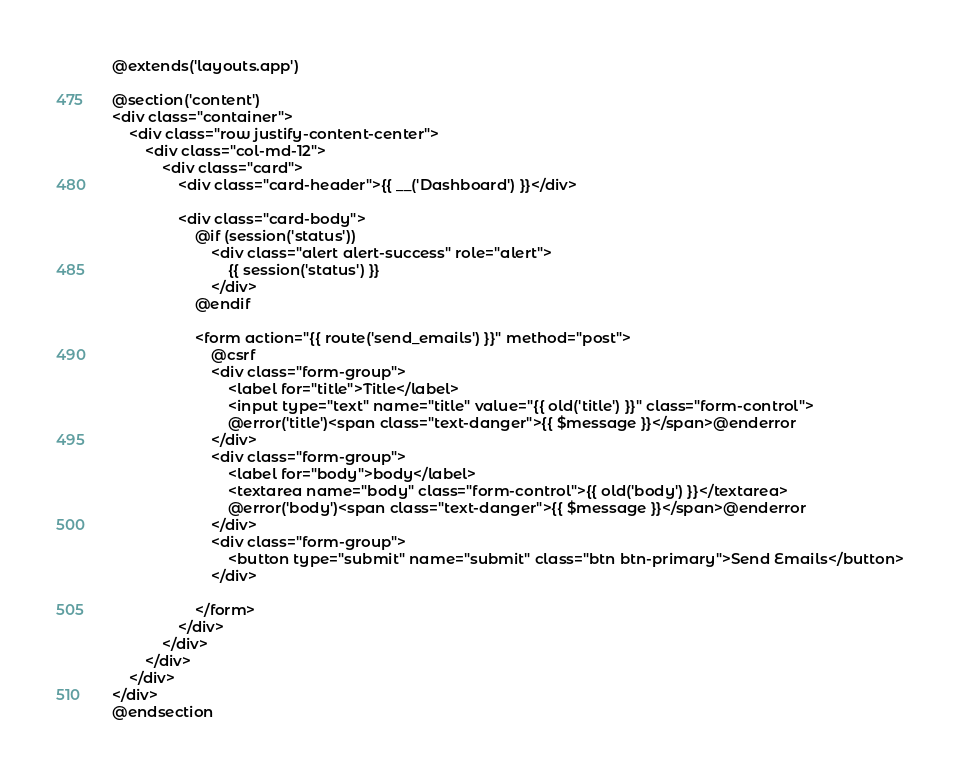Convert code to text. <code><loc_0><loc_0><loc_500><loc_500><_PHP_>@extends('layouts.app')

@section('content')
<div class="container">
    <div class="row justify-content-center">
        <div class="col-md-12">
            <div class="card">
                <div class="card-header">{{ __('Dashboard') }}</div>

                <div class="card-body">
                    @if (session('status'))
                        <div class="alert alert-success" role="alert">
                            {{ session('status') }}
                        </div>
                    @endif

                    <form action="{{ route('send_emails') }}" method="post">
                        @csrf
                        <div class="form-group">
                            <label for="title">Title</label>
                            <input type="text" name="title" value="{{ old('title') }}" class="form-control">
                            @error('title')<span class="text-danger">{{ $message }}</span>@enderror
                        </div>
                        <div class="form-group">
                            <label for="body">body</label>
                            <textarea name="body" class="form-control">{{ old('body') }}</textarea>
                            @error('body')<span class="text-danger">{{ $message }}</span>@enderror
                        </div>
                        <div class="form-group">
                            <button type="submit" name="submit" class="btn btn-primary">Send Emails</button>
                        </div>

                    </form>
                </div>
            </div>
        </div>
    </div>
</div>
@endsection
</code> 